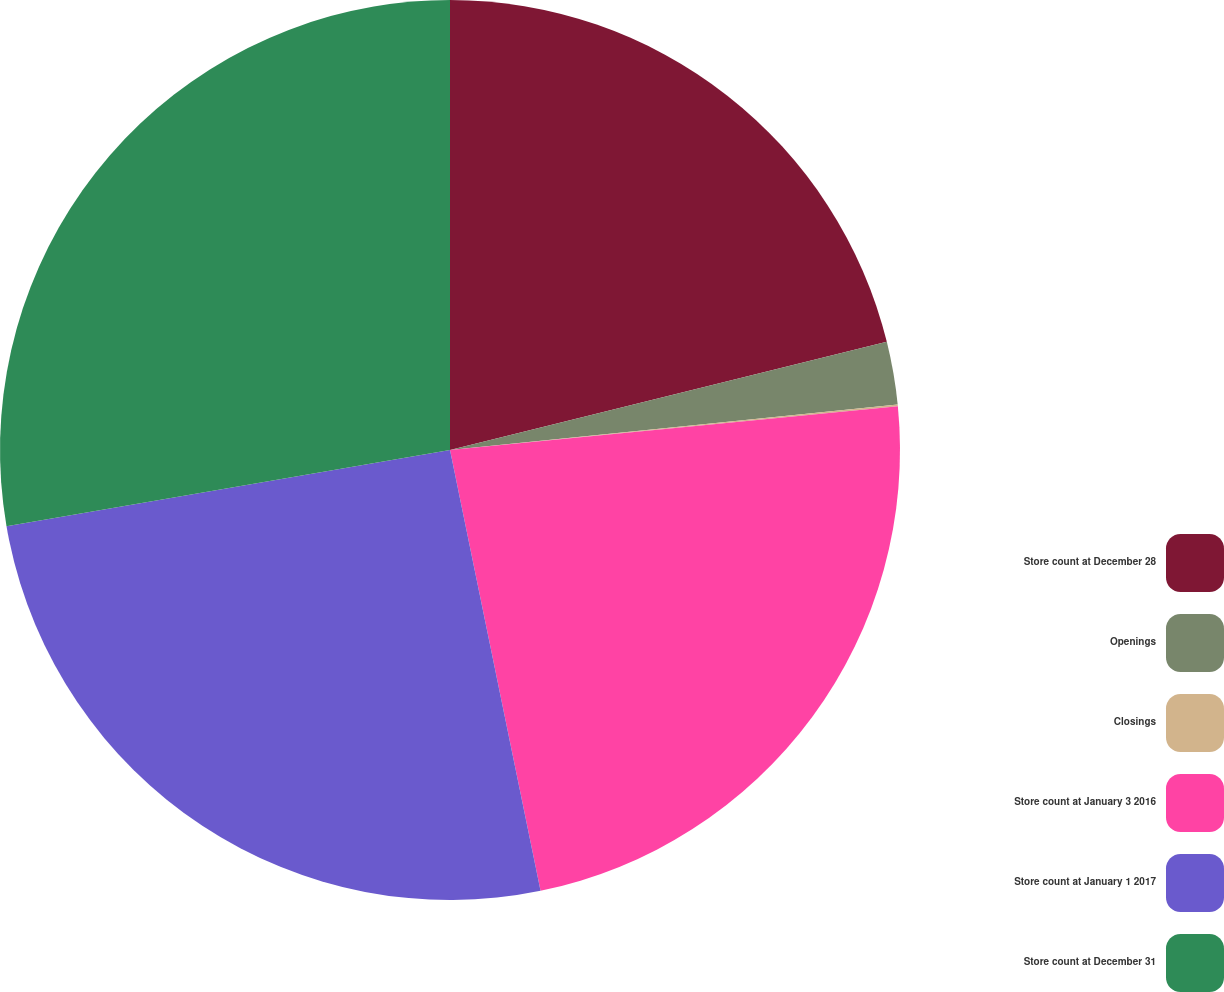Convert chart to OTSL. <chart><loc_0><loc_0><loc_500><loc_500><pie_chart><fcel>Store count at December 28<fcel>Openings<fcel>Closings<fcel>Store count at January 3 2016<fcel>Store count at January 1 2017<fcel>Store count at December 31<nl><fcel>21.14%<fcel>2.25%<fcel>0.06%<fcel>23.33%<fcel>25.52%<fcel>27.71%<nl></chart> 